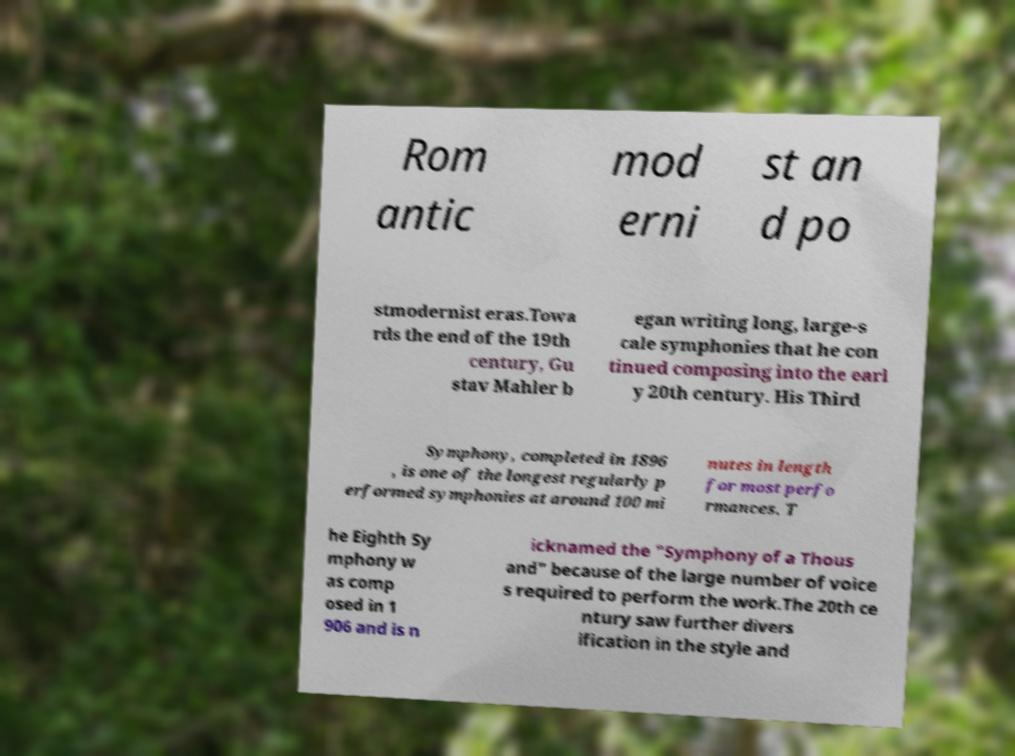Please read and relay the text visible in this image. What does it say? Rom antic mod erni st an d po stmodernist eras.Towa rds the end of the 19th century, Gu stav Mahler b egan writing long, large-s cale symphonies that he con tinued composing into the earl y 20th century. His Third Symphony, completed in 1896 , is one of the longest regularly p erformed symphonies at around 100 mi nutes in length for most perfo rmances. T he Eighth Sy mphony w as comp osed in 1 906 and is n icknamed the "Symphony of a Thous and" because of the large number of voice s required to perform the work.The 20th ce ntury saw further divers ification in the style and 